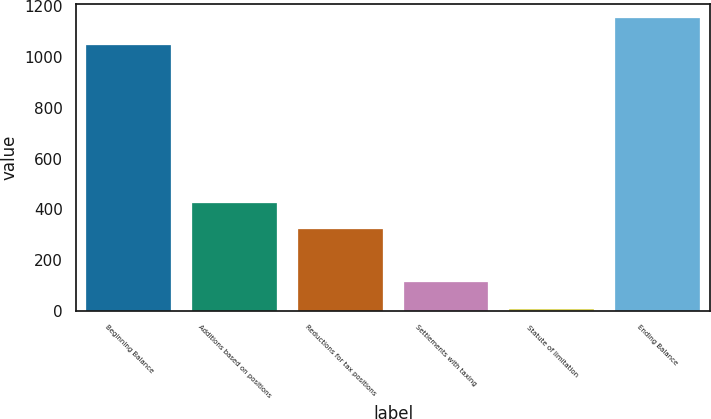Convert chart to OTSL. <chart><loc_0><loc_0><loc_500><loc_500><bar_chart><fcel>Beginning Balance<fcel>Additions based on positions<fcel>Reductions for tax positions<fcel>Settlements with taxing<fcel>Statute of limitation<fcel>Ending Balance<nl><fcel>1047<fcel>426.6<fcel>321.7<fcel>111.9<fcel>7<fcel>1151.9<nl></chart> 